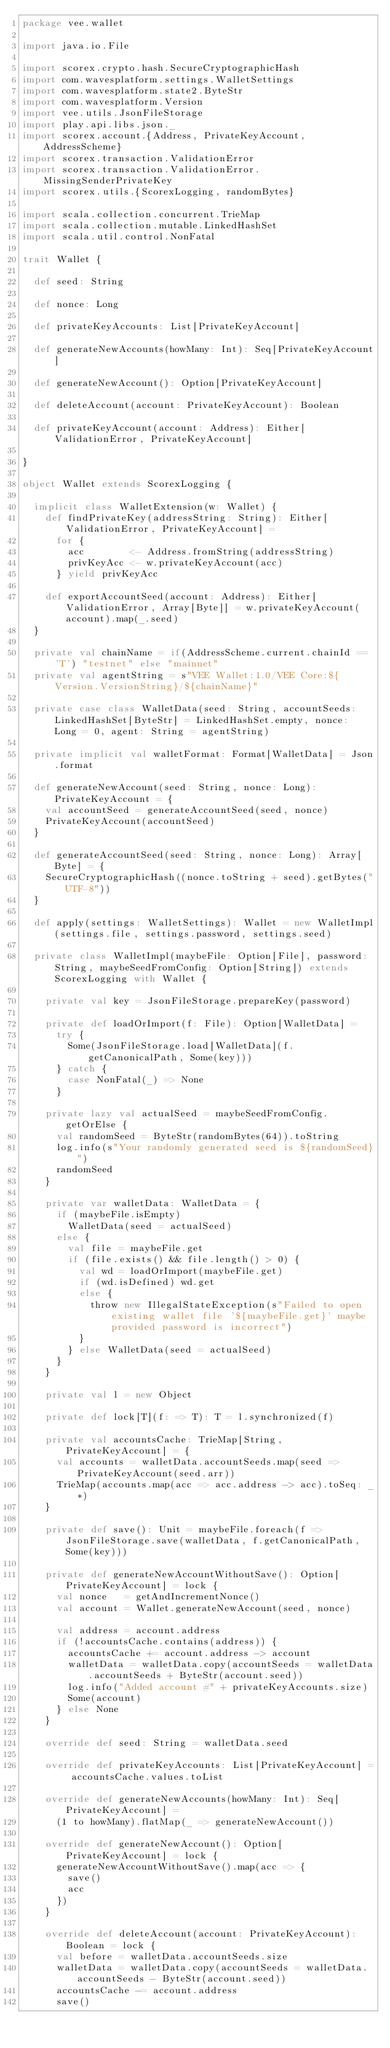<code> <loc_0><loc_0><loc_500><loc_500><_Scala_>package vee.wallet

import java.io.File

import scorex.crypto.hash.SecureCryptographicHash
import com.wavesplatform.settings.WalletSettings
import com.wavesplatform.state2.ByteStr
import com.wavesplatform.Version
import vee.utils.JsonFileStorage
import play.api.libs.json._
import scorex.account.{Address, PrivateKeyAccount, AddressScheme}
import scorex.transaction.ValidationError
import scorex.transaction.ValidationError.MissingSenderPrivateKey
import scorex.utils.{ScorexLogging, randomBytes}

import scala.collection.concurrent.TrieMap
import scala.collection.mutable.LinkedHashSet
import scala.util.control.NonFatal

trait Wallet {

  def seed: String

  def nonce: Long

  def privateKeyAccounts: List[PrivateKeyAccount]

  def generateNewAccounts(howMany: Int): Seq[PrivateKeyAccount]

  def generateNewAccount(): Option[PrivateKeyAccount]

  def deleteAccount(account: PrivateKeyAccount): Boolean

  def privateKeyAccount(account: Address): Either[ValidationError, PrivateKeyAccount]

}

object Wallet extends ScorexLogging {

  implicit class WalletExtension(w: Wallet) {
    def findPrivateKey(addressString: String): Either[ValidationError, PrivateKeyAccount] =
      for {
        acc        <- Address.fromString(addressString)
        privKeyAcc <- w.privateKeyAccount(acc)
      } yield privKeyAcc

    def exportAccountSeed(account: Address): Either[ValidationError, Array[Byte]] = w.privateKeyAccount(account).map(_.seed)
  }

  private val chainName = if(AddressScheme.current.chainId == 'T') "testnet" else "mainnet"
  private val agentString = s"VEE Wallet:1.0/VEE Core:${Version.VersionString}/${chainName}"

  private case class WalletData(seed: String, accountSeeds: LinkedHashSet[ByteStr] = LinkedHashSet.empty, nonce: Long = 0, agent: String = agentString)

  private implicit val walletFormat: Format[WalletData] = Json.format

  def generateNewAccount(seed: String, nonce: Long): PrivateKeyAccount = {
    val accountSeed = generateAccountSeed(seed, nonce)
    PrivateKeyAccount(accountSeed)
  }

  def generateAccountSeed(seed: String, nonce: Long): Array[Byte] = {
    SecureCryptographicHash((nonce.toString + seed).getBytes("UTF-8"))
  }

  def apply(settings: WalletSettings): Wallet = new WalletImpl(settings.file, settings.password, settings.seed)

  private class WalletImpl(maybeFile: Option[File], password: String, maybeSeedFromConfig: Option[String]) extends ScorexLogging with Wallet {

    private val key = JsonFileStorage.prepareKey(password)

    private def loadOrImport(f: File): Option[WalletData] =
      try {
        Some(JsonFileStorage.load[WalletData](f.getCanonicalPath, Some(key)))
      } catch {
        case NonFatal(_) => None
      }

    private lazy val actualSeed = maybeSeedFromConfig.getOrElse {
      val randomSeed = ByteStr(randomBytes(64)).toString
      log.info(s"Your randomly generated seed is ${randomSeed}")
      randomSeed
    }

    private var walletData: WalletData = {
      if (maybeFile.isEmpty)
        WalletData(seed = actualSeed)
      else {
        val file = maybeFile.get
        if (file.exists() && file.length() > 0) {
          val wd = loadOrImport(maybeFile.get)
          if (wd.isDefined) wd.get
          else {
            throw new IllegalStateException(s"Failed to open existing wallet file '${maybeFile.get}' maybe provided password is incorrect")
          }
        } else WalletData(seed = actualSeed)
      }
    }

    private val l = new Object

    private def lock[T](f: => T): T = l.synchronized(f)

    private val accountsCache: TrieMap[String, PrivateKeyAccount] = {
      val accounts = walletData.accountSeeds.map(seed => PrivateKeyAccount(seed.arr))
      TrieMap(accounts.map(acc => acc.address -> acc).toSeq: _*)
    }

    private def save(): Unit = maybeFile.foreach(f => JsonFileStorage.save(walletData, f.getCanonicalPath, Some(key)))

    private def generateNewAccountWithoutSave(): Option[PrivateKeyAccount] = lock {
      val nonce   = getAndIncrementNonce()
      val account = Wallet.generateNewAccount(seed, nonce)

      val address = account.address
      if (!accountsCache.contains(address)) {
        accountsCache += account.address -> account
        walletData = walletData.copy(accountSeeds = walletData.accountSeeds + ByteStr(account.seed))
        log.info("Added account #" + privateKeyAccounts.size)
        Some(account)
      } else None
    }

    override def seed: String = walletData.seed

    override def privateKeyAccounts: List[PrivateKeyAccount] = accountsCache.values.toList

    override def generateNewAccounts(howMany: Int): Seq[PrivateKeyAccount] =
      (1 to howMany).flatMap(_ => generateNewAccount())

    override def generateNewAccount(): Option[PrivateKeyAccount] = lock {
      generateNewAccountWithoutSave().map(acc => {
        save()
        acc
      })
    }

    override def deleteAccount(account: PrivateKeyAccount): Boolean = lock {
      val before = walletData.accountSeeds.size
      walletData = walletData.copy(accountSeeds = walletData.accountSeeds - ByteStr(account.seed))
      accountsCache -= account.address
      save()</code> 